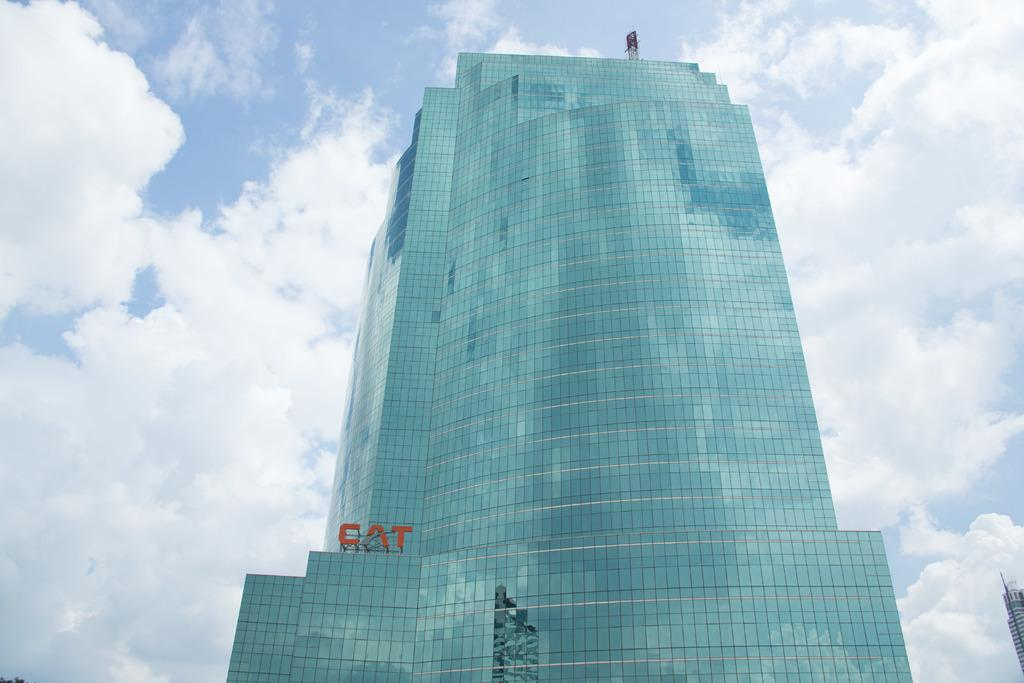Provide a one-sentence caption for the provided image. A huge building with lots of windows and Cat on the building. 